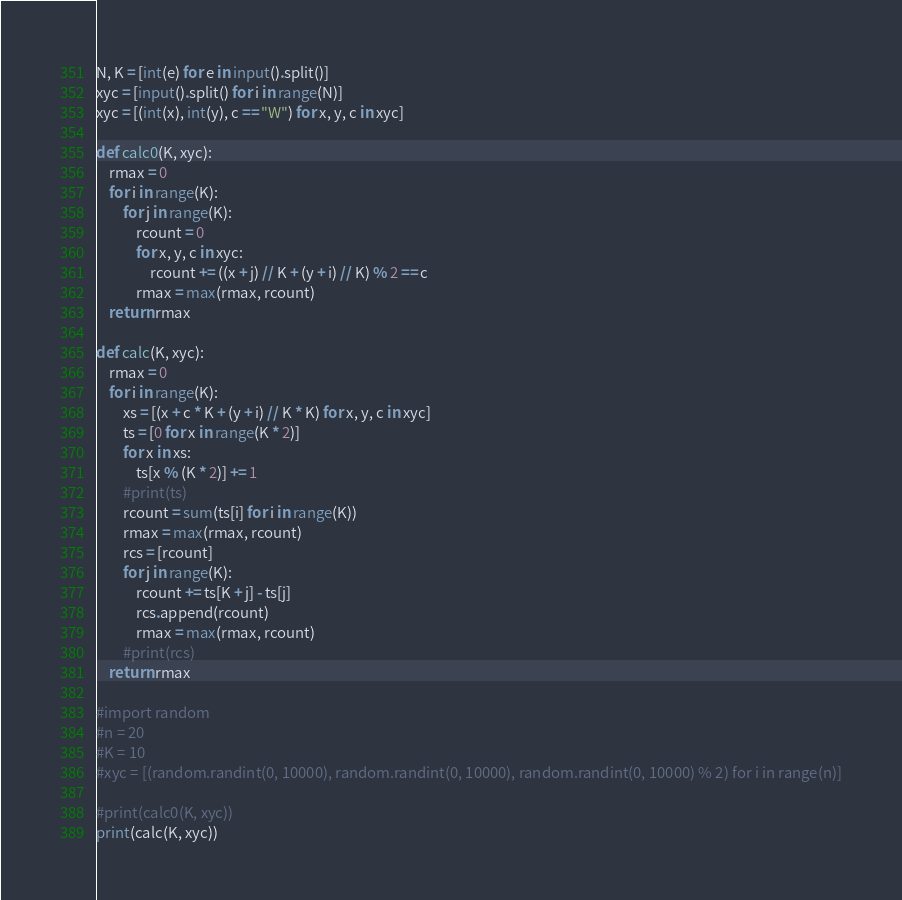Convert code to text. <code><loc_0><loc_0><loc_500><loc_500><_Python_>N, K = [int(e) for e in input().split()]
xyc = [input().split() for i in range(N)]
xyc = [(int(x), int(y), c == "W") for x, y, c in xyc]

def calc0(K, xyc):
    rmax = 0
    for i in range(K):
        for j in range(K):
            rcount = 0
            for x, y, c in xyc:
                rcount += ((x + j) // K + (y + i) // K) % 2 == c
            rmax = max(rmax, rcount)
    return rmax

def calc(K, xyc):
    rmax = 0
    for i in range(K):
        xs = [(x + c * K + (y + i) // K * K) for x, y, c in xyc]
        ts = [0 for x in range(K * 2)]
        for x in xs:
            ts[x % (K * 2)] += 1
        #print(ts)
        rcount = sum(ts[i] for i in range(K))
        rmax = max(rmax, rcount)
        rcs = [rcount]
        for j in range(K):
            rcount += ts[K + j] - ts[j]
            rcs.append(rcount)
            rmax = max(rmax, rcount)
        #print(rcs)
    return rmax

#import random
#n = 20
#K = 10
#xyc = [(random.randint(0, 10000), random.randint(0, 10000), random.randint(0, 10000) % 2) for i in range(n)]

#print(calc0(K, xyc))
print(calc(K, xyc))

</code> 